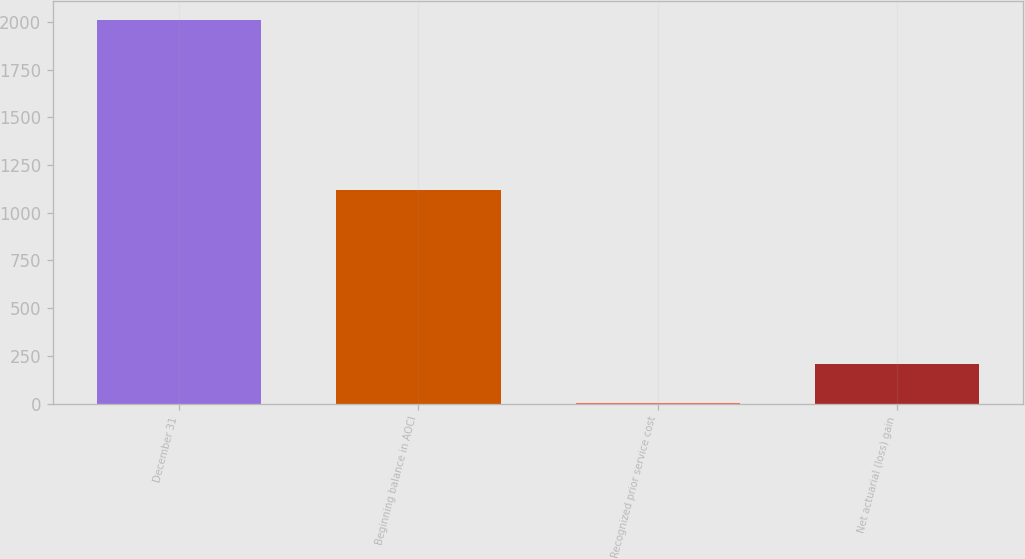Convert chart. <chart><loc_0><loc_0><loc_500><loc_500><bar_chart><fcel>December 31<fcel>Beginning balance in AOCI<fcel>Recognized prior service cost<fcel>Net actuarial (loss) gain<nl><fcel>2010<fcel>1119<fcel>5<fcel>205.5<nl></chart> 